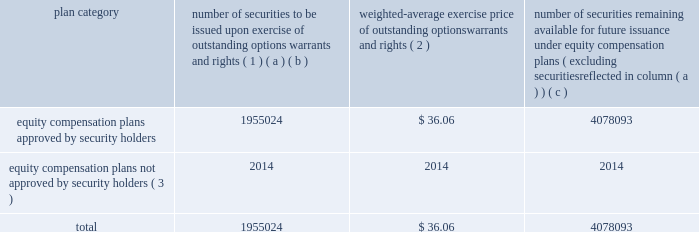Equity compensation plan information the table presents the equity securities available for issuance under our equity compensation plans as of december 31 , 2014 .
Equity compensation plan information plan category number of securities to be issued upon exercise of outstanding options , warrants and rights ( 1 ) weighted-average exercise price of outstanding options , warrants and rights ( 2 ) number of securities remaining available for future issuance under equity compensation plans ( excluding securities reflected in column ( a ) ) ( a ) ( b ) ( c ) equity compensation plans approved by security holders 1955024 $ 36.06 4078093 equity compensation plans not approved by security holders ( 3 ) 2014 2014 2014 .
( 1 ) includes grants made under the huntington ingalls industries , inc .
2012 long-term incentive stock plan ( the "2012 plan" ) , which was approved by our stockholders on may 2 , 2012 , and the huntington ingalls industries , inc .
2011 long-term incentive stock plan ( the "2011 plan" ) , which was approved by the sole stockholder of hii prior to its spin-off from northrop grumman corporation .
Of these shares , 644321 were subject to stock options , 539742 were subject to outstanding restricted performance stock rights , and 63022 were stock rights granted under the 2011 plan .
In addition , this number includes 33571 stock rights , 11046 restricted stock rights and 663322 restricted performance stock rights granted under the 2012 plan , assuming target performance achievement .
( 2 ) this is the weighted average exercise price of the 644321 outstanding stock options only .
( 3 ) there are no awards made under plans not approved by security holders .
Item 13 .
Certain relationships and related transactions , and director independence information as to certain relationships and related transactions and director independence will be incorporated herein by reference to the proxy statement for our 2015 annual meeting of stockholders to be filed within 120 days after the end of the company 2019s fiscal year .
Item 14 .
Principal accountant fees and services information as to principal accountant fees and services will be incorporated herein by reference to the proxy statement for our 2015 annual meeting of stockholders to be filed within 120 days after the end of the company 2019s fiscal year .
This proof is printed at 96% ( 96 % ) of original size this line represents final trim and will not print .
What portion of equity compensation plan is to be issued upon exercise of outstanding options warrants and rights? 
Computations: (1955024 / (1955024 + 4078093))
Answer: 0.32405. 